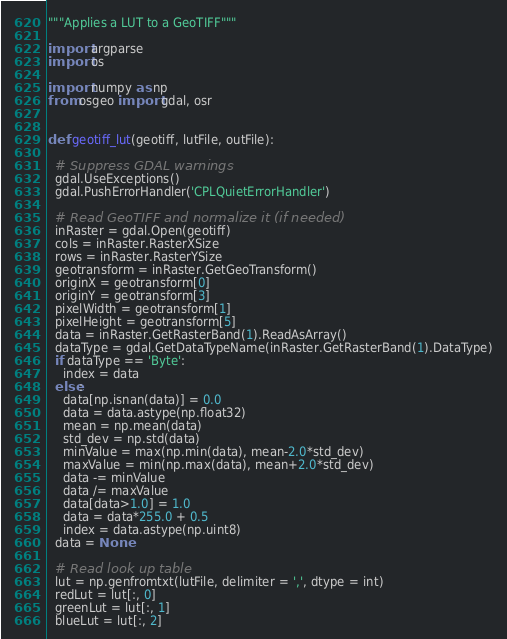Convert code to text. <code><loc_0><loc_0><loc_500><loc_500><_Python_>"""Applies a LUT to a GeoTIFF"""

import argparse
import os

import numpy as np
from osgeo import gdal, osr


def geotiff_lut(geotiff, lutFile, outFile):

  # Suppress GDAL warnings
  gdal.UseExceptions()
  gdal.PushErrorHandler('CPLQuietErrorHandler')

  # Read GeoTIFF and normalize it (if needed)
  inRaster = gdal.Open(geotiff)
  cols = inRaster.RasterXSize
  rows = inRaster.RasterYSize
  geotransform = inRaster.GetGeoTransform()
  originX = geotransform[0]
  originY = geotransform[3]
  pixelWidth = geotransform[1]
  pixelHeight = geotransform[5]
  data = inRaster.GetRasterBand(1).ReadAsArray()
  dataType = gdal.GetDataTypeName(inRaster.GetRasterBand(1).DataType)
  if dataType == 'Byte':
    index = data
  else:
    data[np.isnan(data)] = 0.0
    data = data.astype(np.float32)
    mean = np.mean(data)
    std_dev = np.std(data)
    minValue = max(np.min(data), mean-2.0*std_dev)
    maxValue = min(np.max(data), mean+2.0*std_dev)
    data -= minValue
    data /= maxValue
    data[data>1.0] = 1.0
    data = data*255.0 + 0.5
    index = data.astype(np.uint8)
  data = None

  # Read look up table
  lut = np.genfromtxt(lutFile, delimiter = ',', dtype = int)
  redLut = lut[:, 0]
  greenLut = lut[:, 1]
  blueLut = lut[:, 2]
</code> 